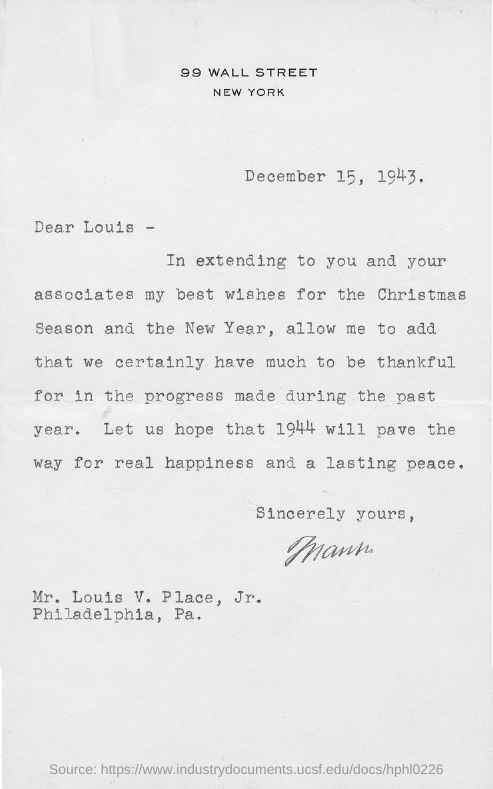Point out several critical features in this image. The date mentioned in the letter is December 15, 1943. Louis V. Place, Jr. resides in Philadelphia, Pennsylvania. The letter is addressed to Louis. The location of 99 Wall Street in New York City is known. Best wishes for a joyous Christmas Season and a prosperous New Year. 